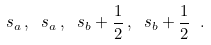Convert formula to latex. <formula><loc_0><loc_0><loc_500><loc_500>s _ { a } \, , \ s _ { a } \, , \ s _ { b } + \frac { 1 } { 2 } \, , \ s _ { b } + \frac { 1 } { 2 } \ .</formula> 